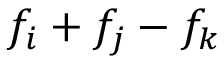Convert formula to latex. <formula><loc_0><loc_0><loc_500><loc_500>f _ { i } + f _ { j } - f _ { k }</formula> 